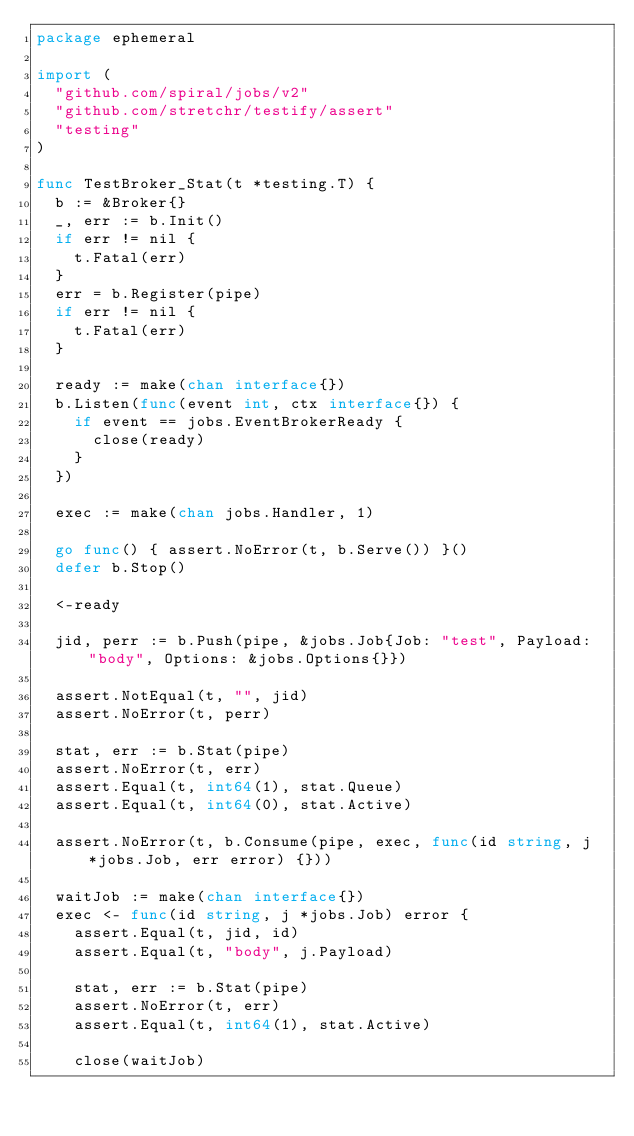Convert code to text. <code><loc_0><loc_0><loc_500><loc_500><_Go_>package ephemeral

import (
	"github.com/spiral/jobs/v2"
	"github.com/stretchr/testify/assert"
	"testing"
)

func TestBroker_Stat(t *testing.T) {
	b := &Broker{}
	_, err := b.Init()
	if err != nil {
		t.Fatal(err)
	}
	err = b.Register(pipe)
	if err != nil {
		t.Fatal(err)
	}

	ready := make(chan interface{})
	b.Listen(func(event int, ctx interface{}) {
		if event == jobs.EventBrokerReady {
			close(ready)
		}
	})

	exec := make(chan jobs.Handler, 1)

	go func() { assert.NoError(t, b.Serve()) }()
	defer b.Stop()

	<-ready

	jid, perr := b.Push(pipe, &jobs.Job{Job: "test", Payload: "body", Options: &jobs.Options{}})

	assert.NotEqual(t, "", jid)
	assert.NoError(t, perr)

	stat, err := b.Stat(pipe)
	assert.NoError(t, err)
	assert.Equal(t, int64(1), stat.Queue)
	assert.Equal(t, int64(0), stat.Active)

	assert.NoError(t, b.Consume(pipe, exec, func(id string, j *jobs.Job, err error) {}))

	waitJob := make(chan interface{})
	exec <- func(id string, j *jobs.Job) error {
		assert.Equal(t, jid, id)
		assert.Equal(t, "body", j.Payload)

		stat, err := b.Stat(pipe)
		assert.NoError(t, err)
		assert.Equal(t, int64(1), stat.Active)

		close(waitJob)</code> 